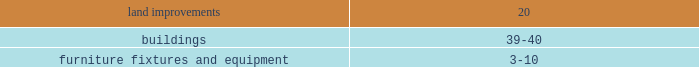The contractual maturities of held-to-maturity securities as of january 30 , 2009 were in excess of three years and were $ 31.4 million at cost and $ 28.9 million at fair value , respectively .
For the successor year ended january 30 , 2009 and period ended february 1 , 2008 , and the predecessor period ended july 6 , 2007 and year ended february 2 , 2007 , gross realized gains and losses on the sales of available-for-sale securities were not material .
The cost of securities sold is based upon the specific identification method .
Merchandise inventories inventories are stated at the lower of cost or market with cost determined using the retail last-in , first-out ( 201clifo 201d ) method .
Under the company 2019s retail inventory method ( 201crim 201d ) , the calculation of gross profit and the resulting valuation of inventories at cost are computed by applying a calculated cost-to-retail inventory ratio to the retail value of sales at a department level .
Costs directly associated with warehousing and distribution are capitalized into inventory .
The excess of current cost over lifo cost was approximately $ 50.0 million at january 30 , 2009 and $ 6.1 million at february 1 , 2008 .
Current cost is determined using the retail first-in , first-out method .
The company 2019s lifo reserves were adjusted to zero at july 6 , 2007 as a result of the merger .
The successor recorded lifo provisions of $ 43.9 million and $ 6.1 million during 2008 and 2007 , respectively .
The predecessor recorded a lifo credit of $ 1.5 million in 2006 .
In 2008 , the increased commodity cost pressures mainly related to food and pet products which have been driven by fruit and vegetable prices and rising freight costs .
Increases in petroleum , resin , metals , pulp and other raw material commodity driven costs also resulted in multiple product cost increases .
The company intends to address these commodity cost increases through negotiations with its vendors and by increasing retail prices as necessary .
On a quarterly basis , the company estimates the annual impact of commodity cost fluctuations based upon the best available information at that point in time .
Store pre-opening costs pre-opening costs related to new store openings and the construction periods are expensed as incurred .
Property and equipment property and equipment are recorded at cost .
The company provides for depreciation and amortization on a straight-line basis over the following estimated useful lives: .
Improvements of leased properties are amortized over the shorter of the life of the applicable lease term or the estimated useful life of the asset. .
What was the total lifo provisions recorded by the successor from 2007 to 2008 in millions? 
Rationale: the total is the sum of all amounts
Computations: (43.9 + 6.1)
Answer: 50.0. 